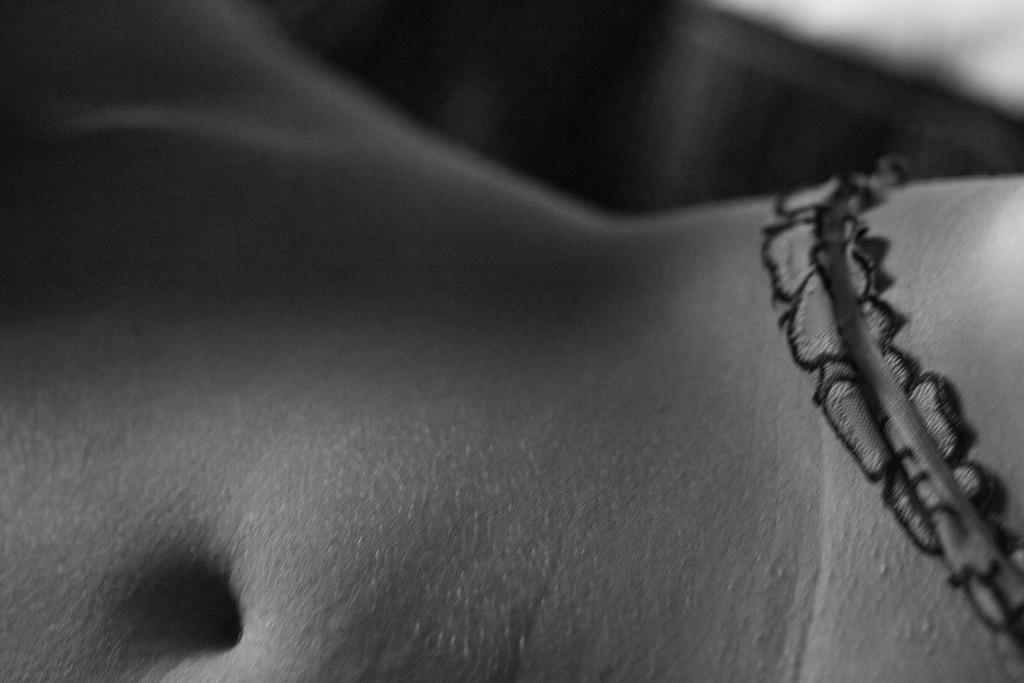What is the main subject of the image? The main subject of the image is a body. What specific feature can be observed on the body? The body has a navel. Are there any additional details on the body? Yes, there is a strip on the body. What type of design can be seen on the house in the image? There is no house present in the image; it features a body with a navel and a strip. How many drops of water are visible on the body in the image? There are no drops of water visible on the body in the image. 